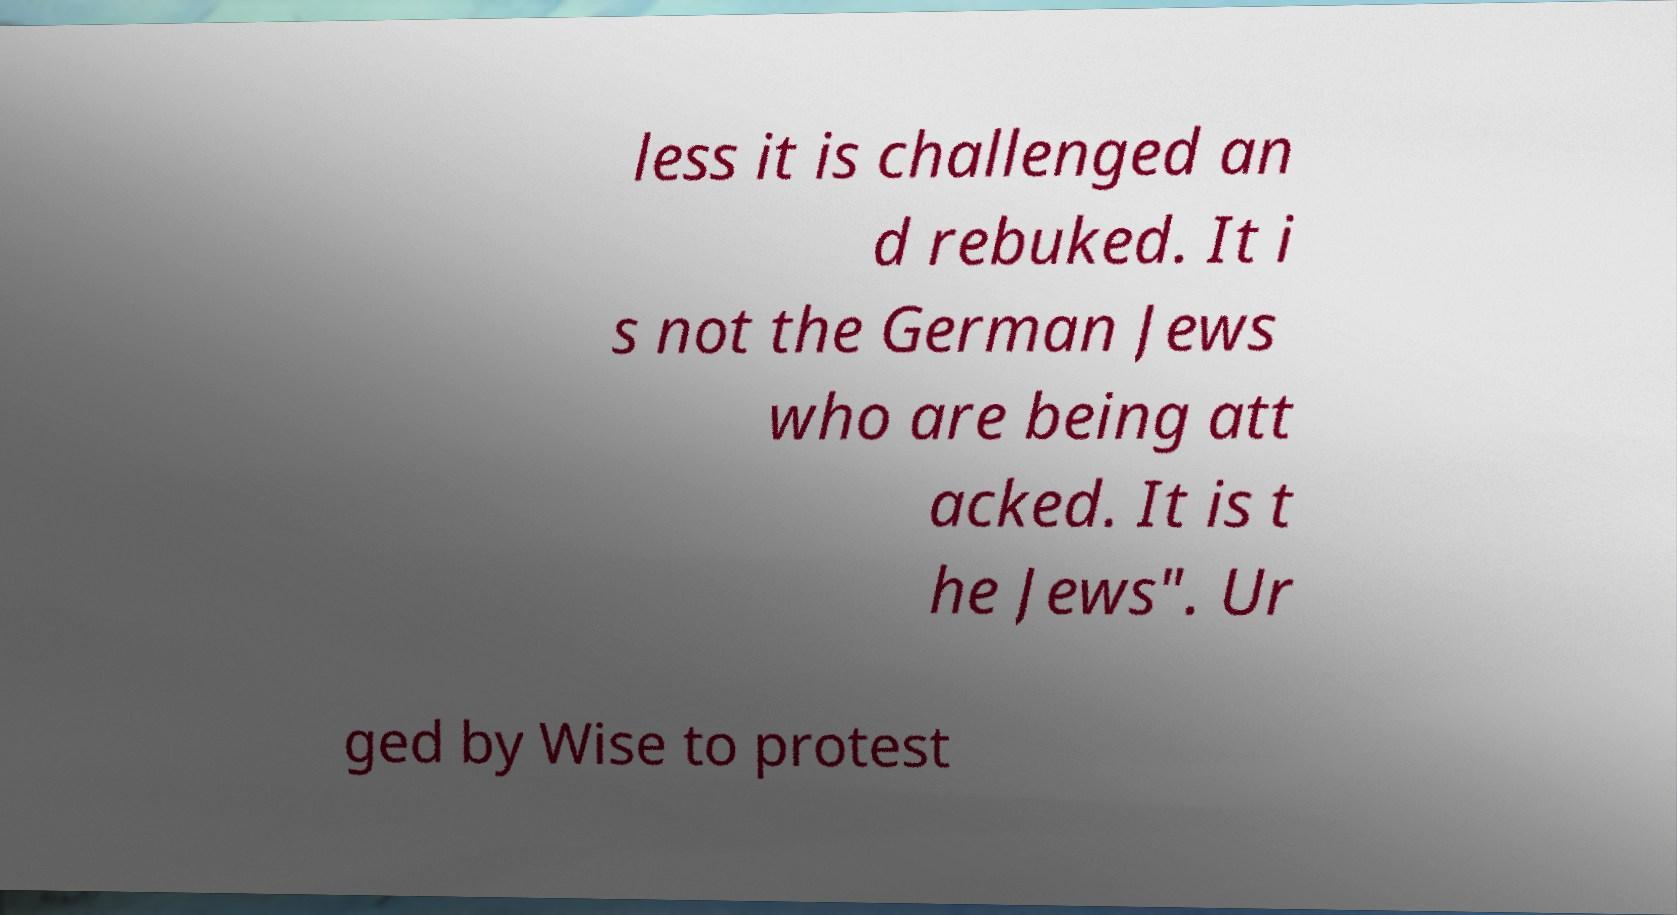Could you assist in decoding the text presented in this image and type it out clearly? less it is challenged an d rebuked. It i s not the German Jews who are being att acked. It is t he Jews". Ur ged by Wise to protest 